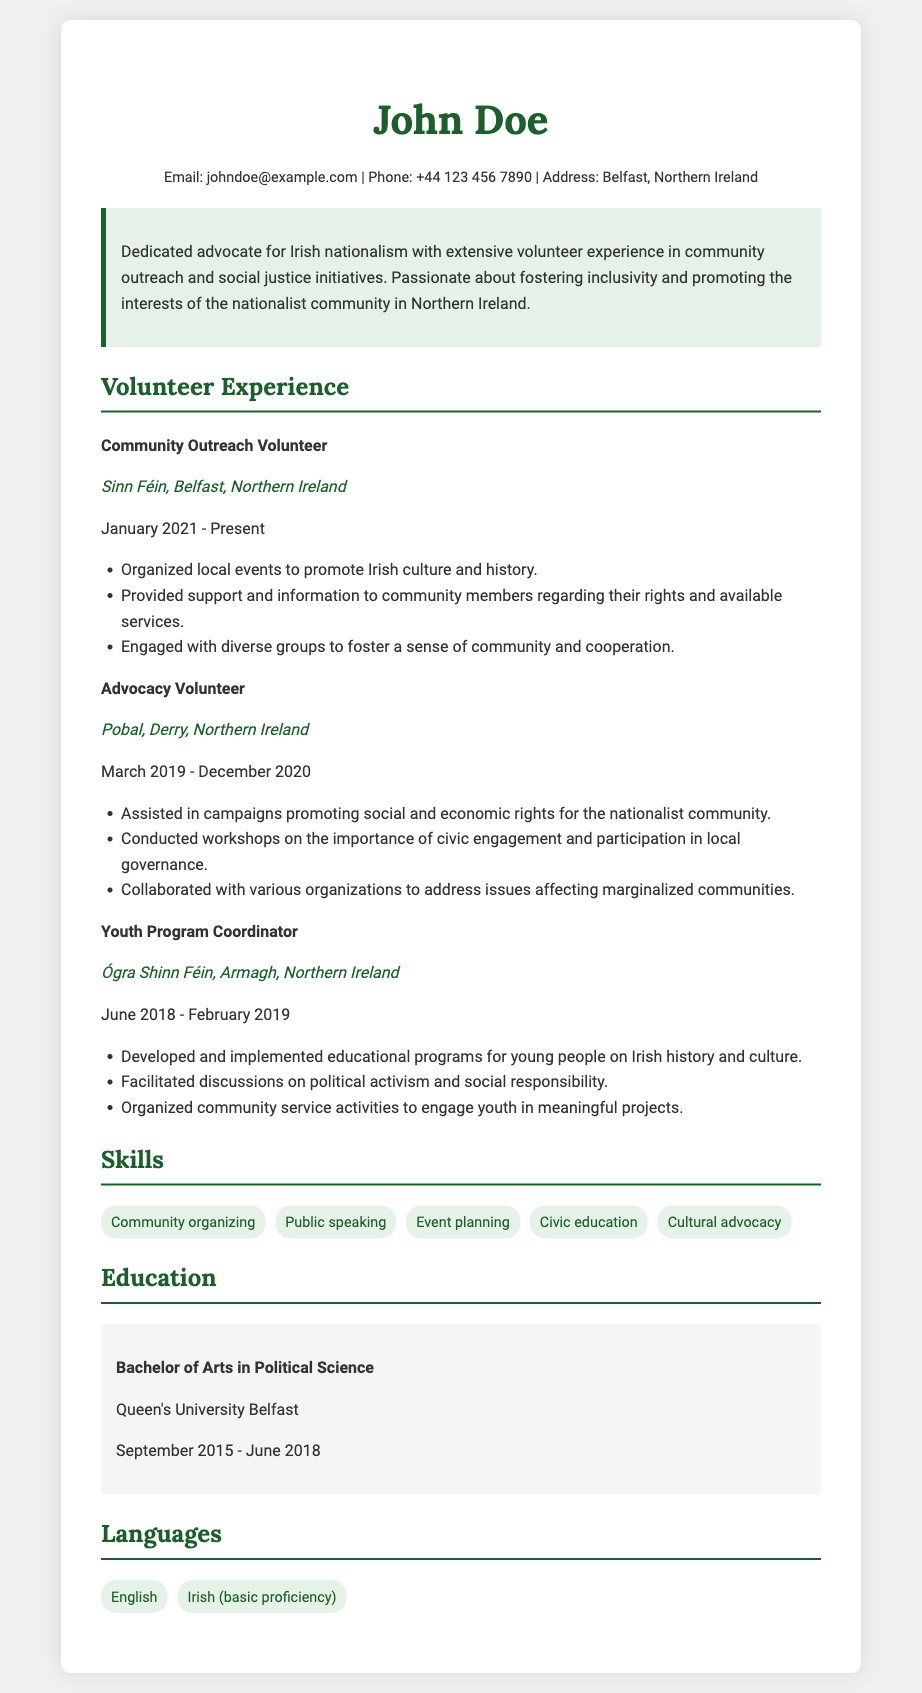What is the name of the individual in the resume? The name mentioned prominently at the top of the resume is "John Doe."
Answer: John Doe Which organization did the individual volunteer for as a Youth Program Coordinator? The resume specifies the organization where the individual worked as a Youth Program Coordinator is "Ógra Shinn Féin."
Answer: Ógra Shinn Féin What degree did John Doe earn, and from which university? The education section lists the degree as "Bachelor of Arts in Political Science" from "Queen's University Belfast."
Answer: Bachelor of Arts in Political Science, Queen's University Belfast How many skills are listed in the skills section? The skills section presents a total of five different skills.
Answer: 5 What is the role of the individual at Sinn Féin? The resume states that John Doe is a "Community Outreach Volunteer" at Sinn Féin.
Answer: Community Outreach Volunteer When did John Doe serve as an Advocacy Volunteer? The resume indicates that the individual served as an Advocacy Volunteer from "March 2019 to December 2020."
Answer: March 2019 - December 2020 